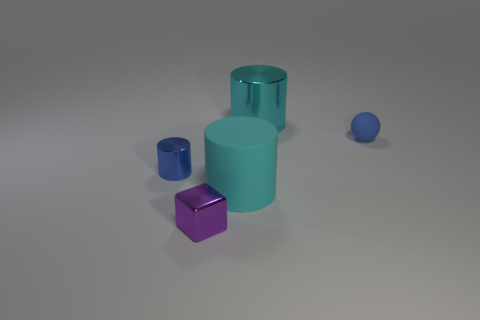Can you describe the lighting and shadows in the image? The lighting in the image is soft and diffused, casting gentle shadows that indicate a light source positioned above the objects, likely simulating an overcast day or soft interior lighting. 